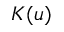<formula> <loc_0><loc_0><loc_500><loc_500>K ( u )</formula> 